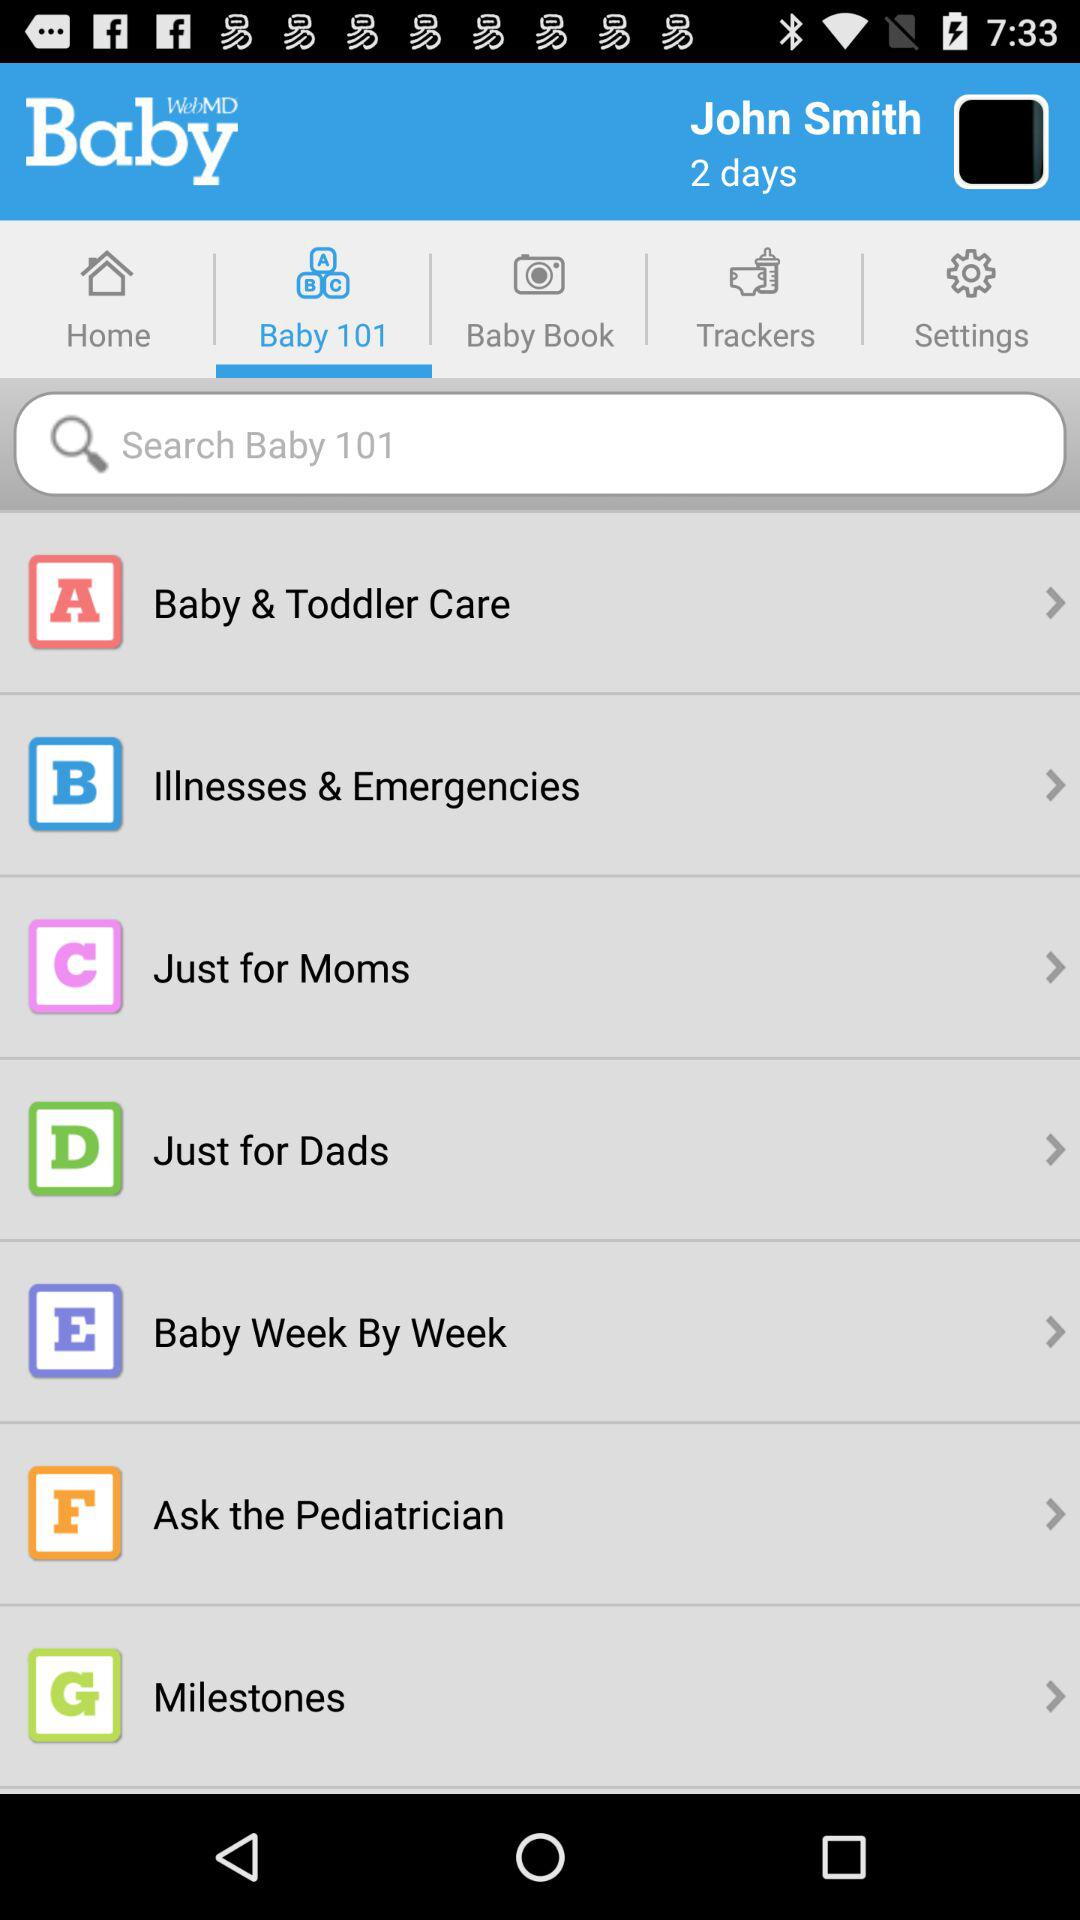What is the selected option? The selected option is "Baby 101". 